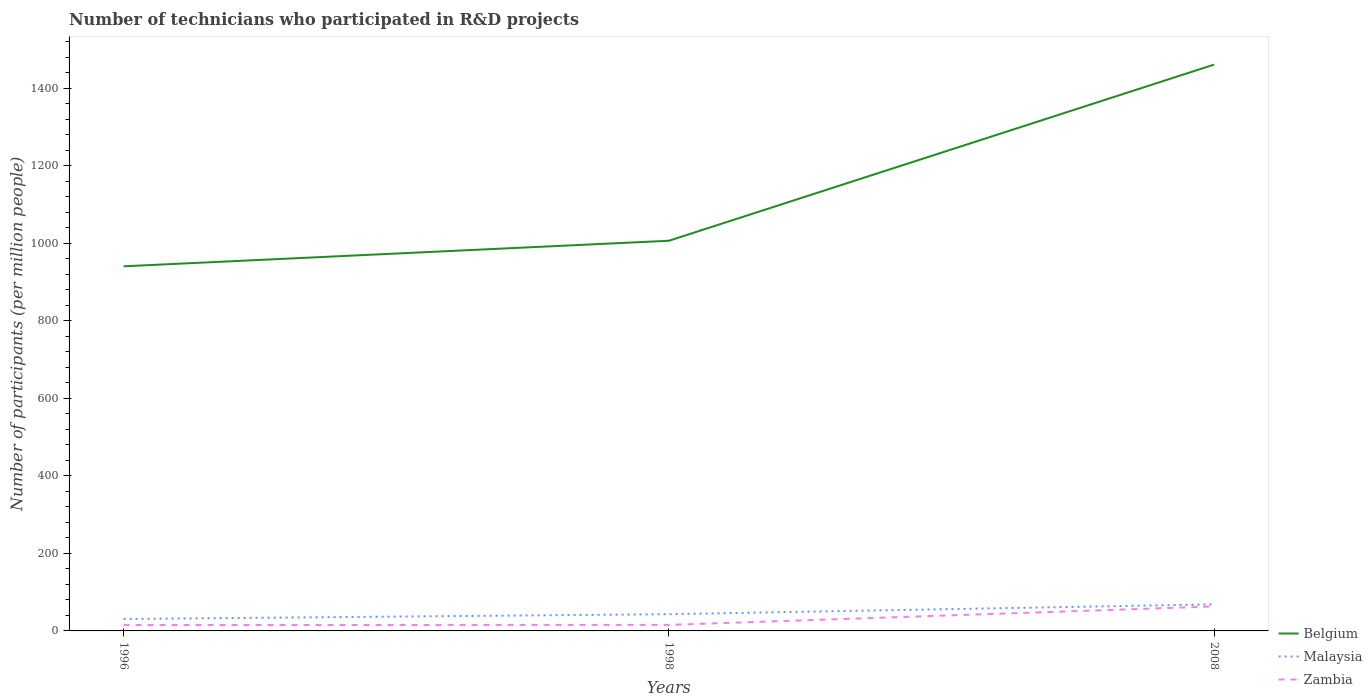How many different coloured lines are there?
Offer a terse response. 3. Does the line corresponding to Malaysia intersect with the line corresponding to Belgium?
Make the answer very short. No. Across all years, what is the maximum number of technicians who participated in R&D projects in Malaysia?
Provide a succinct answer. 30.81. What is the total number of technicians who participated in R&D projects in Zambia in the graph?
Provide a succinct answer. -47.67. What is the difference between the highest and the second highest number of technicians who participated in R&D projects in Belgium?
Your answer should be compact. 520.55. What is the difference between the highest and the lowest number of technicians who participated in R&D projects in Malaysia?
Make the answer very short. 1. Are the values on the major ticks of Y-axis written in scientific E-notation?
Your response must be concise. No. How many legend labels are there?
Make the answer very short. 3. How are the legend labels stacked?
Keep it short and to the point. Vertical. What is the title of the graph?
Offer a terse response. Number of technicians who participated in R&D projects. What is the label or title of the X-axis?
Your answer should be very brief. Years. What is the label or title of the Y-axis?
Give a very brief answer. Number of participants (per million people). What is the Number of participants (per million people) of Belgium in 1996?
Make the answer very short. 940.98. What is the Number of participants (per million people) in Malaysia in 1996?
Make the answer very short. 30.81. What is the Number of participants (per million people) of Zambia in 1996?
Make the answer very short. 15.15. What is the Number of participants (per million people) of Belgium in 1998?
Provide a succinct answer. 1006.9. What is the Number of participants (per million people) of Malaysia in 1998?
Provide a short and direct response. 43.21. What is the Number of participants (per million people) of Zambia in 1998?
Make the answer very short. 15.55. What is the Number of participants (per million people) in Belgium in 2008?
Offer a very short reply. 1461.53. What is the Number of participants (per million people) in Malaysia in 2008?
Give a very brief answer. 68.57. What is the Number of participants (per million people) in Zambia in 2008?
Give a very brief answer. 63.21. Across all years, what is the maximum Number of participants (per million people) in Belgium?
Provide a succinct answer. 1461.53. Across all years, what is the maximum Number of participants (per million people) of Malaysia?
Give a very brief answer. 68.57. Across all years, what is the maximum Number of participants (per million people) in Zambia?
Ensure brevity in your answer.  63.21. Across all years, what is the minimum Number of participants (per million people) in Belgium?
Ensure brevity in your answer.  940.98. Across all years, what is the minimum Number of participants (per million people) of Malaysia?
Keep it short and to the point. 30.81. Across all years, what is the minimum Number of participants (per million people) in Zambia?
Your answer should be very brief. 15.15. What is the total Number of participants (per million people) of Belgium in the graph?
Give a very brief answer. 3409.42. What is the total Number of participants (per million people) in Malaysia in the graph?
Offer a very short reply. 142.59. What is the total Number of participants (per million people) in Zambia in the graph?
Give a very brief answer. 93.91. What is the difference between the Number of participants (per million people) in Belgium in 1996 and that in 1998?
Ensure brevity in your answer.  -65.92. What is the difference between the Number of participants (per million people) in Malaysia in 1996 and that in 1998?
Your response must be concise. -12.4. What is the difference between the Number of participants (per million people) of Zambia in 1996 and that in 1998?
Offer a terse response. -0.39. What is the difference between the Number of participants (per million people) of Belgium in 1996 and that in 2008?
Your answer should be compact. -520.55. What is the difference between the Number of participants (per million people) in Malaysia in 1996 and that in 2008?
Ensure brevity in your answer.  -37.77. What is the difference between the Number of participants (per million people) in Zambia in 1996 and that in 2008?
Keep it short and to the point. -48.06. What is the difference between the Number of participants (per million people) of Belgium in 1998 and that in 2008?
Your response must be concise. -454.63. What is the difference between the Number of participants (per million people) in Malaysia in 1998 and that in 2008?
Keep it short and to the point. -25.37. What is the difference between the Number of participants (per million people) in Zambia in 1998 and that in 2008?
Offer a very short reply. -47.67. What is the difference between the Number of participants (per million people) of Belgium in 1996 and the Number of participants (per million people) of Malaysia in 1998?
Provide a short and direct response. 897.77. What is the difference between the Number of participants (per million people) in Belgium in 1996 and the Number of participants (per million people) in Zambia in 1998?
Provide a succinct answer. 925.43. What is the difference between the Number of participants (per million people) in Malaysia in 1996 and the Number of participants (per million people) in Zambia in 1998?
Make the answer very short. 15.26. What is the difference between the Number of participants (per million people) in Belgium in 1996 and the Number of participants (per million people) in Malaysia in 2008?
Make the answer very short. 872.41. What is the difference between the Number of participants (per million people) of Belgium in 1996 and the Number of participants (per million people) of Zambia in 2008?
Your answer should be compact. 877.77. What is the difference between the Number of participants (per million people) of Malaysia in 1996 and the Number of participants (per million people) of Zambia in 2008?
Offer a terse response. -32.4. What is the difference between the Number of participants (per million people) in Belgium in 1998 and the Number of participants (per million people) in Malaysia in 2008?
Make the answer very short. 938.33. What is the difference between the Number of participants (per million people) of Belgium in 1998 and the Number of participants (per million people) of Zambia in 2008?
Make the answer very short. 943.69. What is the difference between the Number of participants (per million people) of Malaysia in 1998 and the Number of participants (per million people) of Zambia in 2008?
Give a very brief answer. -20.01. What is the average Number of participants (per million people) in Belgium per year?
Your answer should be very brief. 1136.47. What is the average Number of participants (per million people) in Malaysia per year?
Offer a very short reply. 47.53. What is the average Number of participants (per million people) in Zambia per year?
Make the answer very short. 31.3. In the year 1996, what is the difference between the Number of participants (per million people) of Belgium and Number of participants (per million people) of Malaysia?
Provide a short and direct response. 910.17. In the year 1996, what is the difference between the Number of participants (per million people) in Belgium and Number of participants (per million people) in Zambia?
Your response must be concise. 925.83. In the year 1996, what is the difference between the Number of participants (per million people) of Malaysia and Number of participants (per million people) of Zambia?
Offer a terse response. 15.65. In the year 1998, what is the difference between the Number of participants (per million people) in Belgium and Number of participants (per million people) in Malaysia?
Ensure brevity in your answer.  963.7. In the year 1998, what is the difference between the Number of participants (per million people) in Belgium and Number of participants (per million people) in Zambia?
Keep it short and to the point. 991.36. In the year 1998, what is the difference between the Number of participants (per million people) of Malaysia and Number of participants (per million people) of Zambia?
Provide a short and direct response. 27.66. In the year 2008, what is the difference between the Number of participants (per million people) of Belgium and Number of participants (per million people) of Malaysia?
Provide a succinct answer. 1392.96. In the year 2008, what is the difference between the Number of participants (per million people) in Belgium and Number of participants (per million people) in Zambia?
Offer a terse response. 1398.32. In the year 2008, what is the difference between the Number of participants (per million people) of Malaysia and Number of participants (per million people) of Zambia?
Your answer should be very brief. 5.36. What is the ratio of the Number of participants (per million people) in Belgium in 1996 to that in 1998?
Make the answer very short. 0.93. What is the ratio of the Number of participants (per million people) in Malaysia in 1996 to that in 1998?
Give a very brief answer. 0.71. What is the ratio of the Number of participants (per million people) of Zambia in 1996 to that in 1998?
Keep it short and to the point. 0.97. What is the ratio of the Number of participants (per million people) of Belgium in 1996 to that in 2008?
Keep it short and to the point. 0.64. What is the ratio of the Number of participants (per million people) of Malaysia in 1996 to that in 2008?
Keep it short and to the point. 0.45. What is the ratio of the Number of participants (per million people) in Zambia in 1996 to that in 2008?
Provide a succinct answer. 0.24. What is the ratio of the Number of participants (per million people) in Belgium in 1998 to that in 2008?
Offer a terse response. 0.69. What is the ratio of the Number of participants (per million people) of Malaysia in 1998 to that in 2008?
Offer a terse response. 0.63. What is the ratio of the Number of participants (per million people) of Zambia in 1998 to that in 2008?
Your answer should be very brief. 0.25. What is the difference between the highest and the second highest Number of participants (per million people) of Belgium?
Make the answer very short. 454.63. What is the difference between the highest and the second highest Number of participants (per million people) of Malaysia?
Give a very brief answer. 25.37. What is the difference between the highest and the second highest Number of participants (per million people) of Zambia?
Give a very brief answer. 47.67. What is the difference between the highest and the lowest Number of participants (per million people) in Belgium?
Give a very brief answer. 520.55. What is the difference between the highest and the lowest Number of participants (per million people) of Malaysia?
Provide a succinct answer. 37.77. What is the difference between the highest and the lowest Number of participants (per million people) in Zambia?
Offer a terse response. 48.06. 